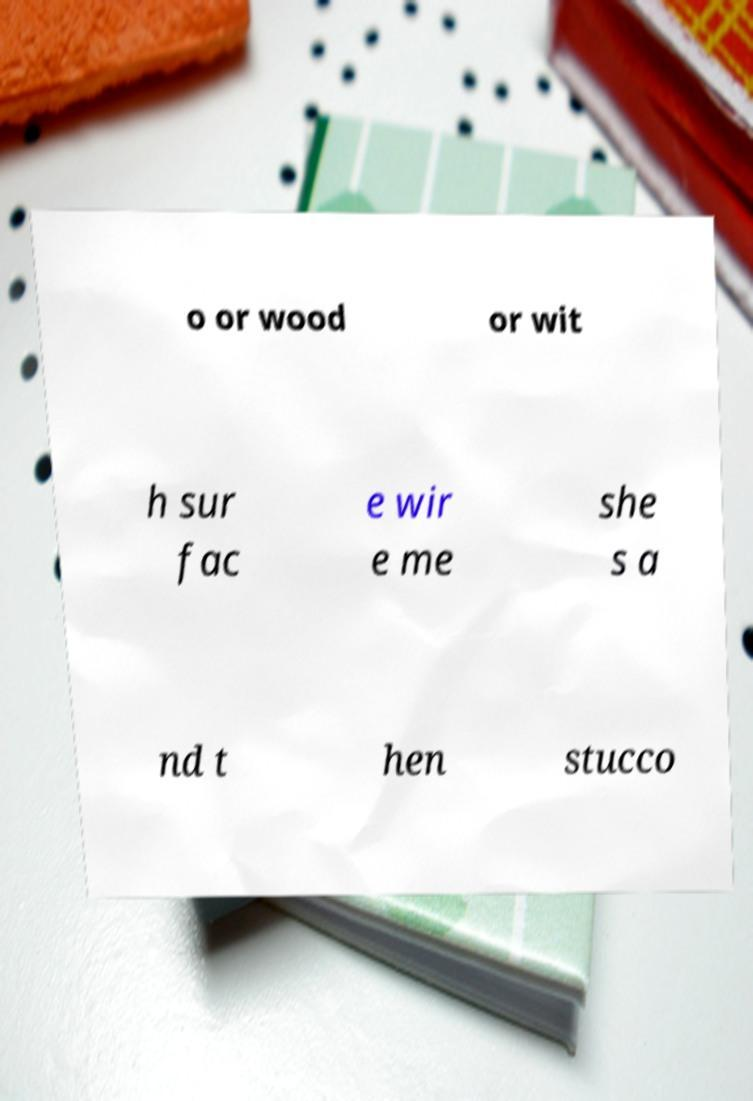Please read and relay the text visible in this image. What does it say? o or wood or wit h sur fac e wir e me she s a nd t hen stucco 